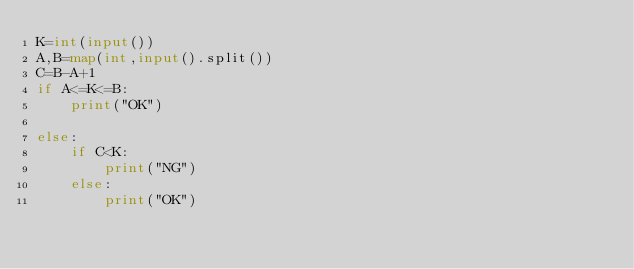<code> <loc_0><loc_0><loc_500><loc_500><_Python_>K=int(input())
A,B=map(int,input().split())
C=B-A+1
if A<=K<=B:
    print("OK")

else:
    if C<K:
        print("NG")
    else:
        print("OK")
</code> 